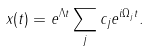Convert formula to latex. <formula><loc_0><loc_0><loc_500><loc_500>x ( t ) = e ^ { \Lambda t } \sum _ { j } c _ { j } e ^ { i \Omega _ { j } t } .</formula> 